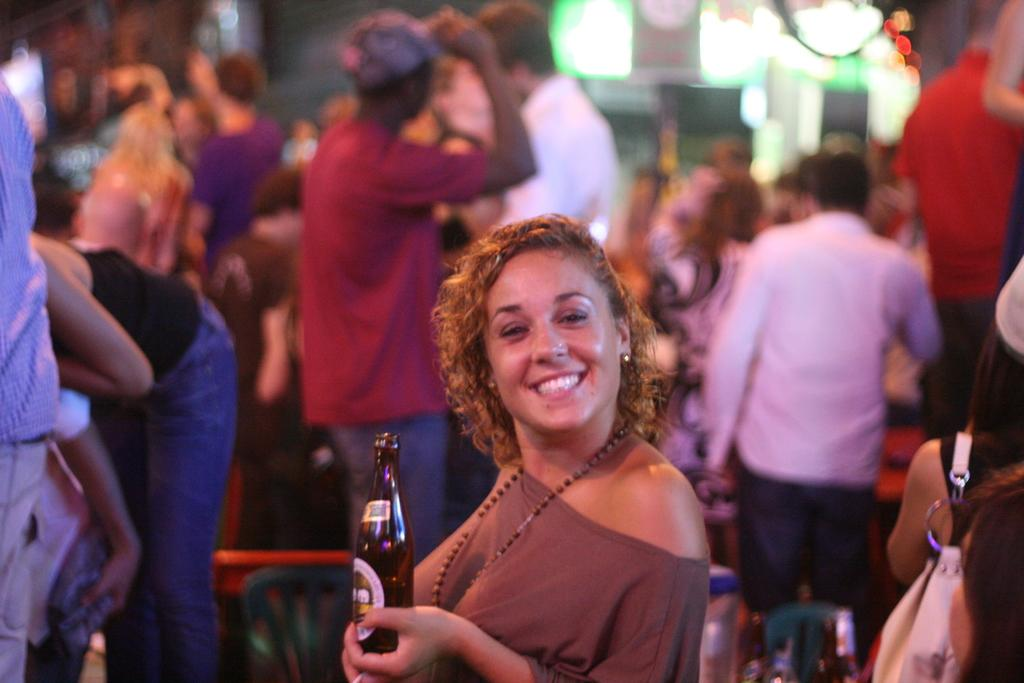How many people are in the image? There are people in the image, but the exact number is not specified. What is one person holding in the image? One person is holding a bottle in the image. Can you describe the lady in the image? The lady in the image is wearing a bag. What can be seen in the image that provides illumination? There are lights visible in the image. What type of stew is being prepared by the people in the image? There is no indication in the image that the people are preparing stew, so it cannot be determined from the picture. 